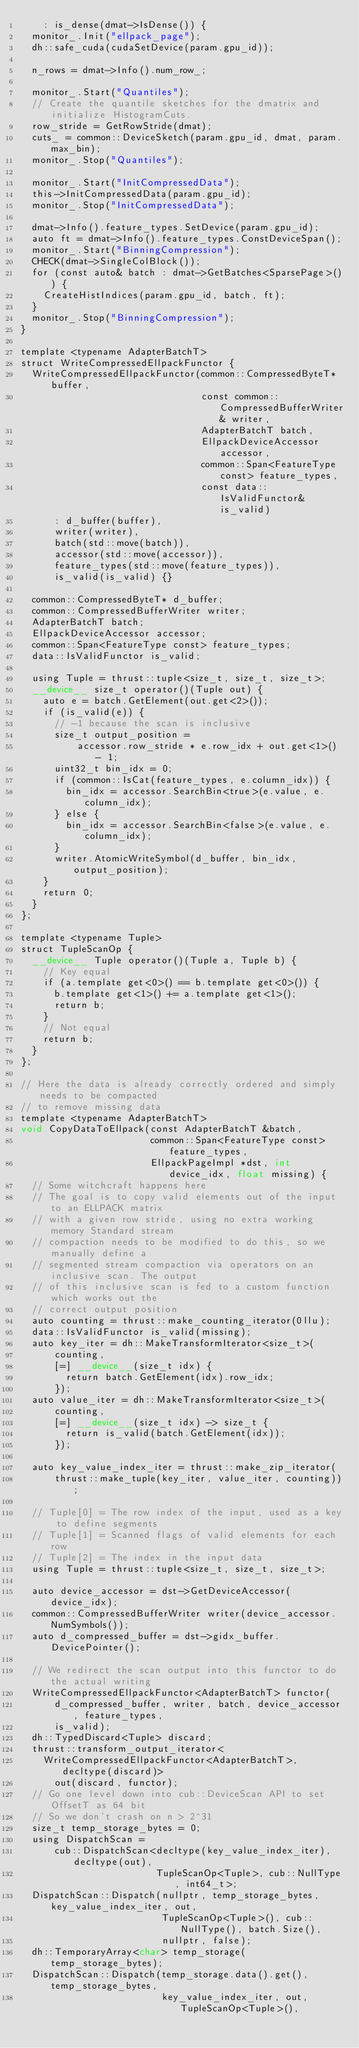<code> <loc_0><loc_0><loc_500><loc_500><_Cuda_>    : is_dense(dmat->IsDense()) {
  monitor_.Init("ellpack_page");
  dh::safe_cuda(cudaSetDevice(param.gpu_id));

  n_rows = dmat->Info().num_row_;

  monitor_.Start("Quantiles");
  // Create the quantile sketches for the dmatrix and initialize HistogramCuts.
  row_stride = GetRowStride(dmat);
  cuts_ = common::DeviceSketch(param.gpu_id, dmat, param.max_bin);
  monitor_.Stop("Quantiles");

  monitor_.Start("InitCompressedData");
  this->InitCompressedData(param.gpu_id);
  monitor_.Stop("InitCompressedData");

  dmat->Info().feature_types.SetDevice(param.gpu_id);
  auto ft = dmat->Info().feature_types.ConstDeviceSpan();
  monitor_.Start("BinningCompression");
  CHECK(dmat->SingleColBlock());
  for (const auto& batch : dmat->GetBatches<SparsePage>()) {
    CreateHistIndices(param.gpu_id, batch, ft);
  }
  monitor_.Stop("BinningCompression");
}

template <typename AdapterBatchT>
struct WriteCompressedEllpackFunctor {
  WriteCompressedEllpackFunctor(common::CompressedByteT* buffer,
                                const common::CompressedBufferWriter& writer,
                                AdapterBatchT batch,
                                EllpackDeviceAccessor accessor,
                                common::Span<FeatureType const> feature_types,
                                const data::IsValidFunctor& is_valid)
      : d_buffer(buffer),
      writer(writer),
      batch(std::move(batch)),
      accessor(std::move(accessor)),
      feature_types(std::move(feature_types)),
      is_valid(is_valid) {}

  common::CompressedByteT* d_buffer;
  common::CompressedBufferWriter writer;
  AdapterBatchT batch;
  EllpackDeviceAccessor accessor;
  common::Span<FeatureType const> feature_types;
  data::IsValidFunctor is_valid;

  using Tuple = thrust::tuple<size_t, size_t, size_t>;
  __device__ size_t operator()(Tuple out) {
    auto e = batch.GetElement(out.get<2>());
    if (is_valid(e)) {
      // -1 because the scan is inclusive
      size_t output_position =
          accessor.row_stride * e.row_idx + out.get<1>() - 1;
      uint32_t bin_idx = 0;
      if (common::IsCat(feature_types, e.column_idx)) {
        bin_idx = accessor.SearchBin<true>(e.value, e.column_idx);
      } else {
        bin_idx = accessor.SearchBin<false>(e.value, e.column_idx);
      }
      writer.AtomicWriteSymbol(d_buffer, bin_idx, output_position);
    }
    return 0;
  }
};

template <typename Tuple>
struct TupleScanOp {
  __device__ Tuple operator()(Tuple a, Tuple b) {
    // Key equal
    if (a.template get<0>() == b.template get<0>()) {
      b.template get<1>() += a.template get<1>();
      return b;
    }
    // Not equal
    return b;
  }
};

// Here the data is already correctly ordered and simply needs to be compacted
// to remove missing data
template <typename AdapterBatchT>
void CopyDataToEllpack(const AdapterBatchT &batch,
                       common::Span<FeatureType const> feature_types,
                       EllpackPageImpl *dst, int device_idx, float missing) {
  // Some witchcraft happens here
  // The goal is to copy valid elements out of the input to an ELLPACK matrix
  // with a given row stride, using no extra working memory Standard stream
  // compaction needs to be modified to do this, so we manually define a
  // segmented stream compaction via operators on an inclusive scan. The output
  // of this inclusive scan is fed to a custom function which works out the
  // correct output position
  auto counting = thrust::make_counting_iterator(0llu);
  data::IsValidFunctor is_valid(missing);
  auto key_iter = dh::MakeTransformIterator<size_t>(
      counting,
      [=] __device__(size_t idx) {
        return batch.GetElement(idx).row_idx;
      });
  auto value_iter = dh::MakeTransformIterator<size_t>(
      counting,
      [=] __device__(size_t idx) -> size_t {
        return is_valid(batch.GetElement(idx));
      });

  auto key_value_index_iter = thrust::make_zip_iterator(
      thrust::make_tuple(key_iter, value_iter, counting));

  // Tuple[0] = The row index of the input, used as a key to define segments
  // Tuple[1] = Scanned flags of valid elements for each row
  // Tuple[2] = The index in the input data
  using Tuple = thrust::tuple<size_t, size_t, size_t>;

  auto device_accessor = dst->GetDeviceAccessor(device_idx);
  common::CompressedBufferWriter writer(device_accessor.NumSymbols());
  auto d_compressed_buffer = dst->gidx_buffer.DevicePointer();

  // We redirect the scan output into this functor to do the actual writing
  WriteCompressedEllpackFunctor<AdapterBatchT> functor(
      d_compressed_buffer, writer, batch, device_accessor, feature_types,
      is_valid);
  dh::TypedDiscard<Tuple> discard;
  thrust::transform_output_iterator<
    WriteCompressedEllpackFunctor<AdapterBatchT>, decltype(discard)>
      out(discard, functor);
  // Go one level down into cub::DeviceScan API to set OffsetT as 64 bit
  // So we don't crash on n > 2^31
  size_t temp_storage_bytes = 0;
  using DispatchScan =
      cub::DispatchScan<decltype(key_value_index_iter), decltype(out),
                        TupleScanOp<Tuple>, cub::NullType, int64_t>;
  DispatchScan::Dispatch(nullptr, temp_storage_bytes, key_value_index_iter, out,
                         TupleScanOp<Tuple>(), cub::NullType(), batch.Size(),
                         nullptr, false);
  dh::TemporaryArray<char> temp_storage(temp_storage_bytes);
  DispatchScan::Dispatch(temp_storage.data().get(), temp_storage_bytes,
                         key_value_index_iter, out, TupleScanOp<Tuple>(),</code> 